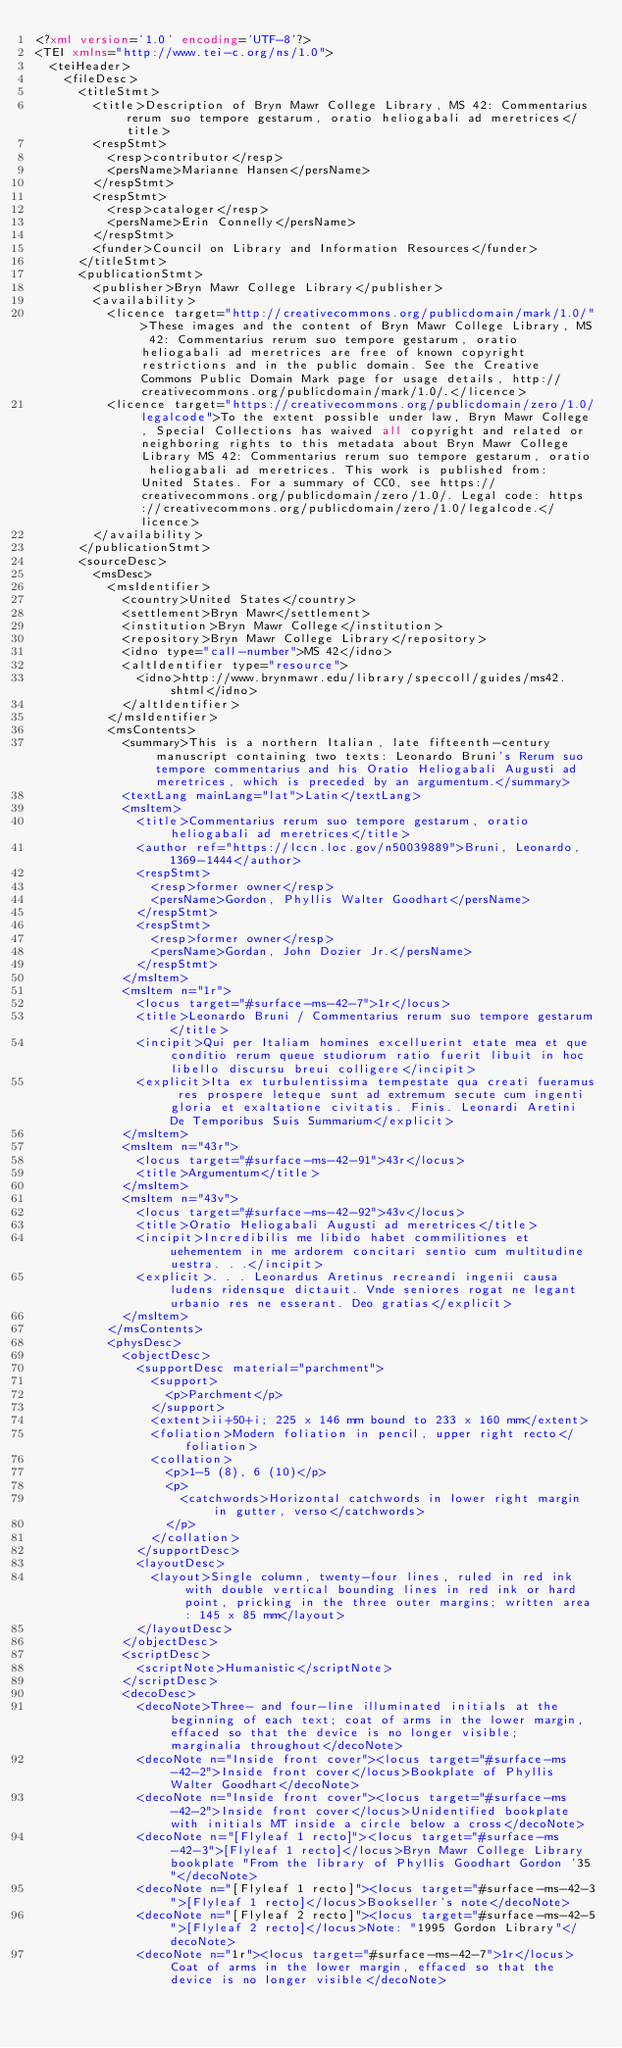Convert code to text. <code><loc_0><loc_0><loc_500><loc_500><_XML_><?xml version='1.0' encoding='UTF-8'?>
<TEI xmlns="http://www.tei-c.org/ns/1.0">
  <teiHeader>
    <fileDesc>
      <titleStmt>
        <title>Description of Bryn Mawr College Library, MS 42: Commentarius rerum suo tempore gestarum, oratio heliogabali ad meretrices</title>
        <respStmt>
          <resp>contributor</resp>
          <persName>Marianne Hansen</persName>
        </respStmt>
        <respStmt>
          <resp>cataloger</resp>
          <persName>Erin Connelly</persName>
        </respStmt>
        <funder>Council on Library and Information Resources</funder>
      </titleStmt>
      <publicationStmt>
        <publisher>Bryn Mawr College Library</publisher>
        <availability>
          <licence target="http://creativecommons.org/publicdomain/mark/1.0/">These images and the content of Bryn Mawr College Library, MS 42: Commentarius rerum suo tempore gestarum, oratio heliogabali ad meretrices are free of known copyright restrictions and in the public domain. See the Creative Commons Public Domain Mark page for usage details, http://creativecommons.org/publicdomain/mark/1.0/.</licence>
          <licence target="https://creativecommons.org/publicdomain/zero/1.0/legalcode">To the extent possible under law, Bryn Mawr College, Special Collections has waived all copyright and related or neighboring rights to this metadata about Bryn Mawr College Library MS 42: Commentarius rerum suo tempore gestarum, oratio heliogabali ad meretrices. This work is published from: United States. For a summary of CC0, see https://creativecommons.org/publicdomain/zero/1.0/. Legal code: https://creativecommons.org/publicdomain/zero/1.0/legalcode.</licence>
        </availability>
      </publicationStmt>
      <sourceDesc>
        <msDesc>
          <msIdentifier>
            <country>United States</country>
            <settlement>Bryn Mawr</settlement>
            <institution>Bryn Mawr College</institution>
            <repository>Bryn Mawr College Library</repository>
            <idno type="call-number">MS 42</idno>
            <altIdentifier type="resource">
              <idno>http://www.brynmawr.edu/library/speccoll/guides/ms42.shtml</idno>
            </altIdentifier>
          </msIdentifier>
          <msContents>
            <summary>This is a northern Italian, late fifteenth-century manuscript containing two texts: Leonardo Bruni's Rerum suo tempore commentarius and his Oratio Heliogabali Augusti ad meretrices, which is preceded by an argumentum.</summary>
            <textLang mainLang="lat">Latin</textLang>
            <msItem>
              <title>Commentarius rerum suo tempore gestarum, oratio heliogabali ad meretrices</title>
              <author ref="https://lccn.loc.gov/n50039889">Bruni, Leonardo, 1369-1444</author>
              <respStmt>
                <resp>former owner</resp>
                <persName>Gordon, Phyllis Walter Goodhart</persName>
              </respStmt>
              <respStmt>
                <resp>former owner</resp>
                <persName>Gordan, John Dozier Jr.</persName>
              </respStmt>
            </msItem>
            <msItem n="1r">
              <locus target="#surface-ms-42-7">1r</locus>
              <title>Leonardo Bruni / Commentarius rerum suo tempore gestarum</title>
              <incipit>Qui per Italiam homines excelluerint etate mea et que conditio rerum queue studiorum ratio fuerit libuit in hoc libello discursu breui colligere</incipit>
              <explicit>Ita ex turbulentissima tempestate qua creati fueramus res prospere leteque sunt ad extremum secute cum ingenti gloria et exaltatione civitatis. Finis. Leonardi Aretini De Temporibus Suis Summarium</explicit>
            </msItem>
            <msItem n="43r">
              <locus target="#surface-ms-42-91">43r</locus>
              <title>Argumentum</title>
            </msItem>
            <msItem n="43v">
              <locus target="#surface-ms-42-92">43v</locus>
              <title>Oratio Heliogabali Augusti ad meretrices</title>
              <incipit>Incredibilis me libido habet commilitiones et uehementem in me ardorem concitari sentio cum multitudine uestra. . .</incipit>
              <explicit>. . . Leonardus Aretinus recreandi ingenii causa ludens ridensque dictauit. Vnde seniores rogat ne legant urbanio res ne esserant. Deo gratias</explicit>
            </msItem>
          </msContents>
          <physDesc>
            <objectDesc>
              <supportDesc material="parchment">
                <support>
                  <p>Parchment</p>
                </support>
                <extent>ii+50+i; 225 x 146 mm bound to 233 x 160 mm</extent>
                <foliation>Modern foliation in pencil, upper right recto</foliation>
                <collation>
                  <p>1-5 (8), 6 (10)</p>
                  <p>
                    <catchwords>Horizontal catchwords in lower right margin in gutter, verso</catchwords>
                  </p>
                </collation>
              </supportDesc>
              <layoutDesc>
                <layout>Single column, twenty-four lines, ruled in red ink with double vertical bounding lines in red ink or hard point, pricking in the three outer margins; written area: 145 x 85 mm</layout>
              </layoutDesc>
            </objectDesc>
            <scriptDesc>
              <scriptNote>Humanistic</scriptNote>
            </scriptDesc>
            <decoDesc>
              <decoNote>Three- and four-line illuminated initials at the beginning of each text; coat of arms in the lower margin, effaced so that the device is no longer visible; marginalia throughout</decoNote>
              <decoNote n="Inside front cover"><locus target="#surface-ms-42-2">Inside front cover</locus>Bookplate of Phyllis Walter Goodhart</decoNote>
              <decoNote n="Inside front cover"><locus target="#surface-ms-42-2">Inside front cover</locus>Unidentified bookplate with initials MT inside a circle below a cross</decoNote>
              <decoNote n="[Flyleaf 1 recto]"><locus target="#surface-ms-42-3">[Flyleaf 1 recto]</locus>Bryn Mawr College Library bookplate "From the library of Phyllis Goodhart Gordon '35"</decoNote>
              <decoNote n="[Flyleaf 1 recto]"><locus target="#surface-ms-42-3">[Flyleaf 1 recto]</locus>Bookseller's note</decoNote>
              <decoNote n="[Flyleaf 2 recto]"><locus target="#surface-ms-42-5">[Flyleaf 2 recto]</locus>Note: "1995 Gordon Library"</decoNote>
              <decoNote n="1r"><locus target="#surface-ms-42-7">1r</locus>Coat of arms in the lower margin, effaced so that the device is no longer visible</decoNote></code> 